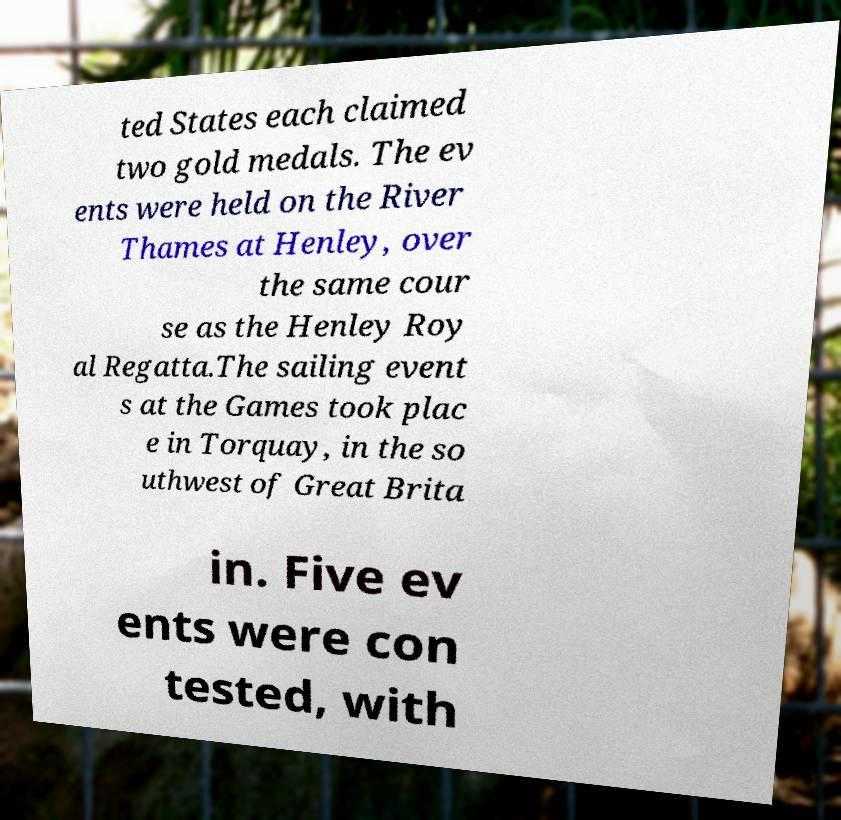Can you accurately transcribe the text from the provided image for me? ted States each claimed two gold medals. The ev ents were held on the River Thames at Henley, over the same cour se as the Henley Roy al Regatta.The sailing event s at the Games took plac e in Torquay, in the so uthwest of Great Brita in. Five ev ents were con tested, with 